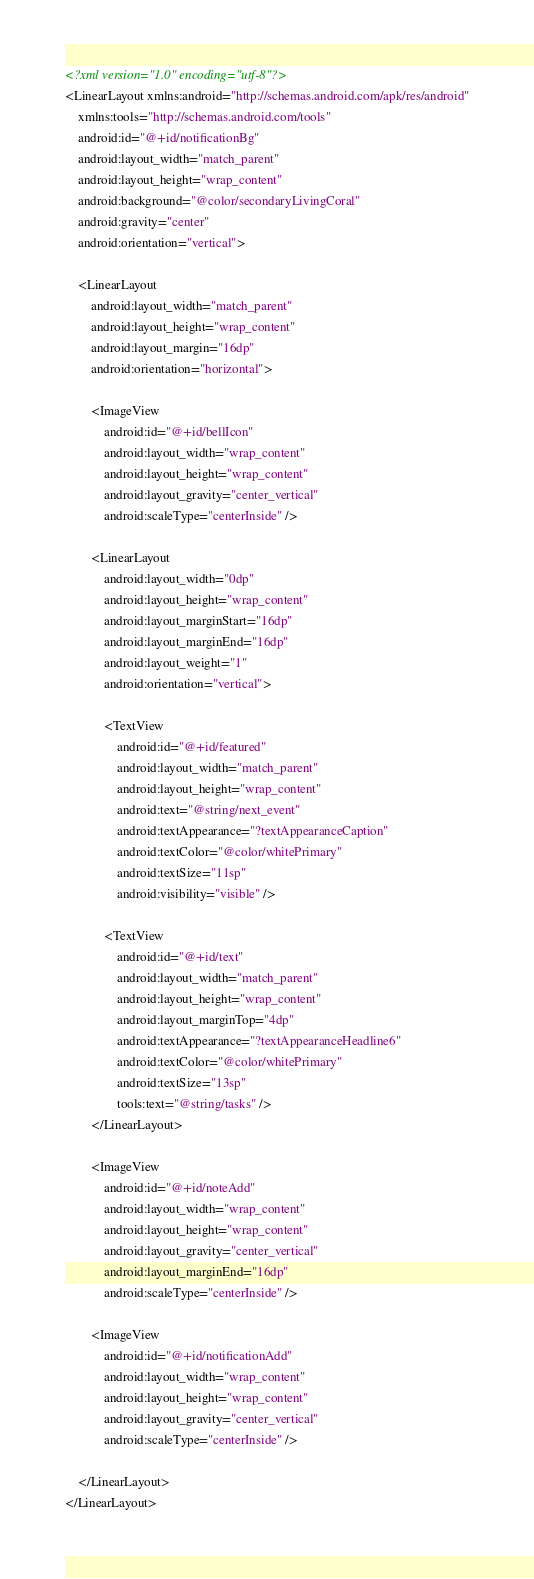<code> <loc_0><loc_0><loc_500><loc_500><_XML_><?xml version="1.0" encoding="utf-8"?>
<LinearLayout xmlns:android="http://schemas.android.com/apk/res/android"
    xmlns:tools="http://schemas.android.com/tools"
    android:id="@+id/notificationBg"
    android:layout_width="match_parent"
    android:layout_height="wrap_content"
    android:background="@color/secondaryLivingCoral"
    android:gravity="center"
    android:orientation="vertical">

    <LinearLayout
        android:layout_width="match_parent"
        android:layout_height="wrap_content"
        android:layout_margin="16dp"
        android:orientation="horizontal">

        <ImageView
            android:id="@+id/bellIcon"
            android:layout_width="wrap_content"
            android:layout_height="wrap_content"
            android:layout_gravity="center_vertical"
            android:scaleType="centerInside" />

        <LinearLayout
            android:layout_width="0dp"
            android:layout_height="wrap_content"
            android:layout_marginStart="16dp"
            android:layout_marginEnd="16dp"
            android:layout_weight="1"
            android:orientation="vertical">

            <TextView
                android:id="@+id/featured"
                android:layout_width="match_parent"
                android:layout_height="wrap_content"
                android:text="@string/next_event"
                android:textAppearance="?textAppearanceCaption"
                android:textColor="@color/whitePrimary"
                android:textSize="11sp"
                android:visibility="visible" />

            <TextView
                android:id="@+id/text"
                android:layout_width="match_parent"
                android:layout_height="wrap_content"
                android:layout_marginTop="4dp"
                android:textAppearance="?textAppearanceHeadline6"
                android:textColor="@color/whitePrimary"
                android:textSize="13sp"
                tools:text="@string/tasks" />
        </LinearLayout>

        <ImageView
            android:id="@+id/noteAdd"
            android:layout_width="wrap_content"
            android:layout_height="wrap_content"
            android:layout_gravity="center_vertical"
            android:layout_marginEnd="16dp"
            android:scaleType="centerInside" />

        <ImageView
            android:id="@+id/notificationAdd"
            android:layout_width="wrap_content"
            android:layout_height="wrap_content"
            android:layout_gravity="center_vertical"
            android:scaleType="centerInside" />

    </LinearLayout>
</LinearLayout></code> 